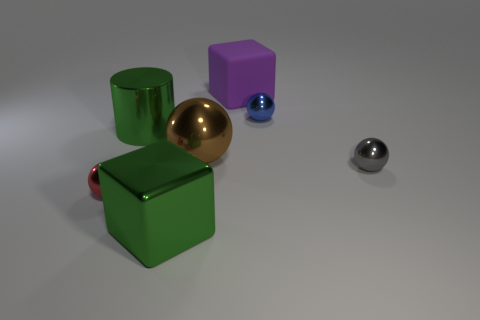How many gray cylinders are there?
Keep it short and to the point. 0. What is the shape of the big metal object that is behind the red object and right of the large green shiny cylinder?
Provide a short and direct response. Sphere. What is the shape of the red metal thing behind the block that is left of the block that is behind the small red object?
Your response must be concise. Sphere. What material is the big thing that is on the right side of the large metallic block and in front of the big purple matte block?
Make the answer very short. Metal. How many objects have the same size as the red sphere?
Provide a short and direct response. 2. What number of matte things are either gray things or small balls?
Provide a short and direct response. 0. What is the material of the cylinder?
Provide a short and direct response. Metal. How many big blocks are in front of the rubber object?
Offer a very short reply. 1. Are the small object to the left of the large green cube and the big purple thing made of the same material?
Offer a terse response. No. How many big metallic objects are the same shape as the purple matte object?
Your response must be concise. 1. 